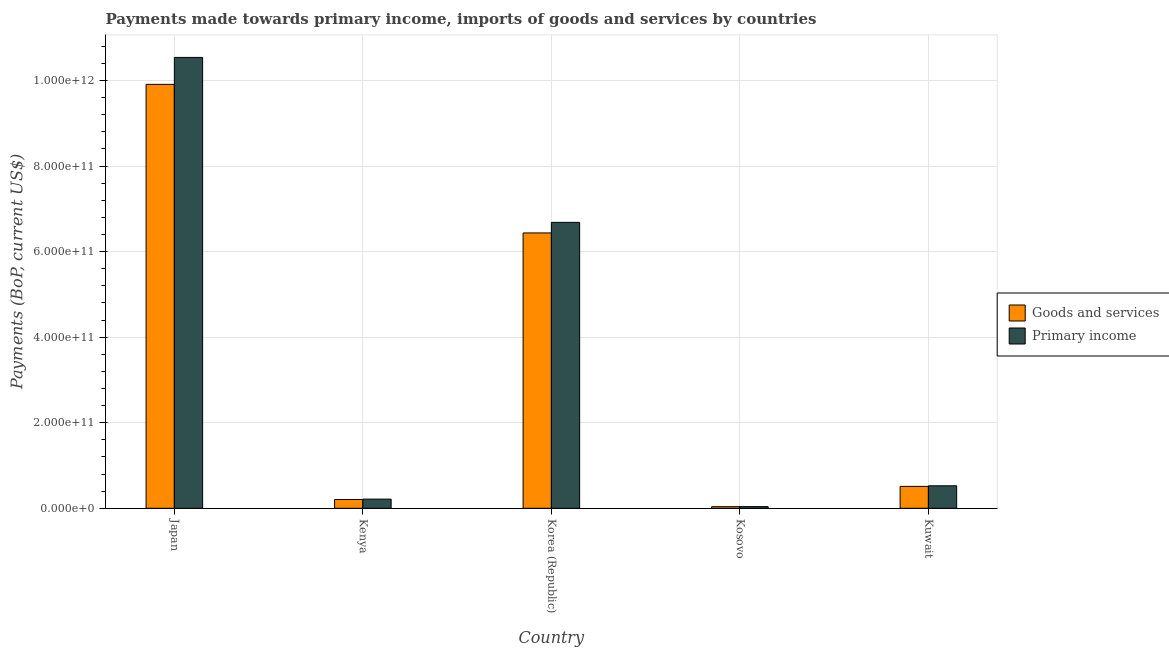Are the number of bars per tick equal to the number of legend labels?
Make the answer very short. Yes. Are the number of bars on each tick of the X-axis equal?
Offer a terse response. Yes. How many bars are there on the 2nd tick from the right?
Provide a succinct answer. 2. What is the label of the 4th group of bars from the left?
Keep it short and to the point. Kosovo. What is the payments made towards goods and services in Kosovo?
Provide a short and direct response. 3.73e+09. Across all countries, what is the maximum payments made towards primary income?
Provide a succinct answer. 1.05e+12. Across all countries, what is the minimum payments made towards goods and services?
Make the answer very short. 3.73e+09. In which country was the payments made towards goods and services maximum?
Provide a succinct answer. Japan. In which country was the payments made towards primary income minimum?
Ensure brevity in your answer.  Kosovo. What is the total payments made towards goods and services in the graph?
Offer a terse response. 1.71e+12. What is the difference between the payments made towards goods and services in Japan and that in Kuwait?
Your answer should be very brief. 9.40e+11. What is the difference between the payments made towards primary income in Japan and the payments made towards goods and services in Korea (Republic)?
Keep it short and to the point. 4.10e+11. What is the average payments made towards primary income per country?
Give a very brief answer. 3.60e+11. What is the difference between the payments made towards goods and services and payments made towards primary income in Japan?
Your answer should be compact. -6.30e+1. What is the ratio of the payments made towards goods and services in Korea (Republic) to that in Kosovo?
Offer a very short reply. 172.73. What is the difference between the highest and the second highest payments made towards goods and services?
Your answer should be very brief. 3.47e+11. What is the difference between the highest and the lowest payments made towards goods and services?
Provide a short and direct response. 9.87e+11. In how many countries, is the payments made towards primary income greater than the average payments made towards primary income taken over all countries?
Give a very brief answer. 2. What does the 2nd bar from the left in Kosovo represents?
Give a very brief answer. Primary income. What does the 1st bar from the right in Japan represents?
Your answer should be very brief. Primary income. Are all the bars in the graph horizontal?
Offer a very short reply. No. What is the difference between two consecutive major ticks on the Y-axis?
Offer a very short reply. 2.00e+11. How many legend labels are there?
Keep it short and to the point. 2. What is the title of the graph?
Provide a short and direct response. Payments made towards primary income, imports of goods and services by countries. What is the label or title of the Y-axis?
Your answer should be very brief. Payments (BoP, current US$). What is the Payments (BoP, current US$) of Goods and services in Japan?
Keep it short and to the point. 9.91e+11. What is the Payments (BoP, current US$) of Primary income in Japan?
Provide a succinct answer. 1.05e+12. What is the Payments (BoP, current US$) in Goods and services in Kenya?
Your answer should be compact. 2.05e+1. What is the Payments (BoP, current US$) in Primary income in Kenya?
Give a very brief answer. 2.14e+1. What is the Payments (BoP, current US$) of Goods and services in Korea (Republic)?
Offer a very short reply. 6.44e+11. What is the Payments (BoP, current US$) in Primary income in Korea (Republic)?
Your answer should be compact. 6.68e+11. What is the Payments (BoP, current US$) in Goods and services in Kosovo?
Provide a short and direct response. 3.73e+09. What is the Payments (BoP, current US$) in Primary income in Kosovo?
Your answer should be very brief. 3.86e+09. What is the Payments (BoP, current US$) of Goods and services in Kuwait?
Your response must be concise. 5.12e+1. What is the Payments (BoP, current US$) of Primary income in Kuwait?
Your response must be concise. 5.26e+1. Across all countries, what is the maximum Payments (BoP, current US$) of Goods and services?
Ensure brevity in your answer.  9.91e+11. Across all countries, what is the maximum Payments (BoP, current US$) in Primary income?
Make the answer very short. 1.05e+12. Across all countries, what is the minimum Payments (BoP, current US$) in Goods and services?
Your answer should be compact. 3.73e+09. Across all countries, what is the minimum Payments (BoP, current US$) of Primary income?
Ensure brevity in your answer.  3.86e+09. What is the total Payments (BoP, current US$) of Goods and services in the graph?
Your answer should be compact. 1.71e+12. What is the total Payments (BoP, current US$) in Primary income in the graph?
Your response must be concise. 1.80e+12. What is the difference between the Payments (BoP, current US$) in Goods and services in Japan and that in Kenya?
Keep it short and to the point. 9.70e+11. What is the difference between the Payments (BoP, current US$) in Primary income in Japan and that in Kenya?
Make the answer very short. 1.03e+12. What is the difference between the Payments (BoP, current US$) in Goods and services in Japan and that in Korea (Republic)?
Offer a very short reply. 3.47e+11. What is the difference between the Payments (BoP, current US$) of Primary income in Japan and that in Korea (Republic)?
Your answer should be compact. 3.86e+11. What is the difference between the Payments (BoP, current US$) in Goods and services in Japan and that in Kosovo?
Your response must be concise. 9.87e+11. What is the difference between the Payments (BoP, current US$) in Primary income in Japan and that in Kosovo?
Offer a very short reply. 1.05e+12. What is the difference between the Payments (BoP, current US$) in Goods and services in Japan and that in Kuwait?
Your answer should be compact. 9.40e+11. What is the difference between the Payments (BoP, current US$) of Primary income in Japan and that in Kuwait?
Offer a very short reply. 1.00e+12. What is the difference between the Payments (BoP, current US$) in Goods and services in Kenya and that in Korea (Republic)?
Your response must be concise. -6.23e+11. What is the difference between the Payments (BoP, current US$) of Primary income in Kenya and that in Korea (Republic)?
Provide a succinct answer. -6.47e+11. What is the difference between the Payments (BoP, current US$) in Goods and services in Kenya and that in Kosovo?
Ensure brevity in your answer.  1.68e+1. What is the difference between the Payments (BoP, current US$) in Primary income in Kenya and that in Kosovo?
Keep it short and to the point. 1.75e+1. What is the difference between the Payments (BoP, current US$) of Goods and services in Kenya and that in Kuwait?
Give a very brief answer. -3.06e+1. What is the difference between the Payments (BoP, current US$) in Primary income in Kenya and that in Kuwait?
Provide a succinct answer. -3.12e+1. What is the difference between the Payments (BoP, current US$) in Goods and services in Korea (Republic) and that in Kosovo?
Provide a short and direct response. 6.40e+11. What is the difference between the Payments (BoP, current US$) in Primary income in Korea (Republic) and that in Kosovo?
Provide a short and direct response. 6.64e+11. What is the difference between the Payments (BoP, current US$) in Goods and services in Korea (Republic) and that in Kuwait?
Give a very brief answer. 5.92e+11. What is the difference between the Payments (BoP, current US$) in Primary income in Korea (Republic) and that in Kuwait?
Provide a short and direct response. 6.16e+11. What is the difference between the Payments (BoP, current US$) in Goods and services in Kosovo and that in Kuwait?
Keep it short and to the point. -4.74e+1. What is the difference between the Payments (BoP, current US$) of Primary income in Kosovo and that in Kuwait?
Keep it short and to the point. -4.87e+1. What is the difference between the Payments (BoP, current US$) of Goods and services in Japan and the Payments (BoP, current US$) of Primary income in Kenya?
Offer a very short reply. 9.70e+11. What is the difference between the Payments (BoP, current US$) of Goods and services in Japan and the Payments (BoP, current US$) of Primary income in Korea (Republic)?
Your answer should be very brief. 3.23e+11. What is the difference between the Payments (BoP, current US$) of Goods and services in Japan and the Payments (BoP, current US$) of Primary income in Kosovo?
Provide a succinct answer. 9.87e+11. What is the difference between the Payments (BoP, current US$) in Goods and services in Japan and the Payments (BoP, current US$) in Primary income in Kuwait?
Offer a terse response. 9.38e+11. What is the difference between the Payments (BoP, current US$) of Goods and services in Kenya and the Payments (BoP, current US$) of Primary income in Korea (Republic)?
Give a very brief answer. -6.48e+11. What is the difference between the Payments (BoP, current US$) in Goods and services in Kenya and the Payments (BoP, current US$) in Primary income in Kosovo?
Offer a very short reply. 1.67e+1. What is the difference between the Payments (BoP, current US$) in Goods and services in Kenya and the Payments (BoP, current US$) in Primary income in Kuwait?
Make the answer very short. -3.20e+1. What is the difference between the Payments (BoP, current US$) of Goods and services in Korea (Republic) and the Payments (BoP, current US$) of Primary income in Kosovo?
Keep it short and to the point. 6.40e+11. What is the difference between the Payments (BoP, current US$) in Goods and services in Korea (Republic) and the Payments (BoP, current US$) in Primary income in Kuwait?
Offer a terse response. 5.91e+11. What is the difference between the Payments (BoP, current US$) in Goods and services in Kosovo and the Payments (BoP, current US$) in Primary income in Kuwait?
Your answer should be very brief. -4.88e+1. What is the average Payments (BoP, current US$) of Goods and services per country?
Provide a succinct answer. 3.42e+11. What is the average Payments (BoP, current US$) in Primary income per country?
Your response must be concise. 3.60e+11. What is the difference between the Payments (BoP, current US$) of Goods and services and Payments (BoP, current US$) of Primary income in Japan?
Give a very brief answer. -6.30e+1. What is the difference between the Payments (BoP, current US$) of Goods and services and Payments (BoP, current US$) of Primary income in Kenya?
Offer a very short reply. -8.64e+08. What is the difference between the Payments (BoP, current US$) in Goods and services and Payments (BoP, current US$) in Primary income in Korea (Republic)?
Your response must be concise. -2.47e+1. What is the difference between the Payments (BoP, current US$) of Goods and services and Payments (BoP, current US$) of Primary income in Kosovo?
Ensure brevity in your answer.  -1.35e+08. What is the difference between the Payments (BoP, current US$) in Goods and services and Payments (BoP, current US$) in Primary income in Kuwait?
Keep it short and to the point. -1.39e+09. What is the ratio of the Payments (BoP, current US$) in Goods and services in Japan to that in Kenya?
Your answer should be very brief. 48.24. What is the ratio of the Payments (BoP, current US$) in Primary income in Japan to that in Kenya?
Offer a terse response. 49.23. What is the ratio of the Payments (BoP, current US$) in Goods and services in Japan to that in Korea (Republic)?
Your answer should be very brief. 1.54. What is the ratio of the Payments (BoP, current US$) in Primary income in Japan to that in Korea (Republic)?
Keep it short and to the point. 1.58. What is the ratio of the Payments (BoP, current US$) in Goods and services in Japan to that in Kosovo?
Keep it short and to the point. 265.94. What is the ratio of the Payments (BoP, current US$) in Primary income in Japan to that in Kosovo?
Give a very brief answer. 272.95. What is the ratio of the Payments (BoP, current US$) of Goods and services in Japan to that in Kuwait?
Provide a succinct answer. 19.36. What is the ratio of the Payments (BoP, current US$) in Primary income in Japan to that in Kuwait?
Your answer should be compact. 20.05. What is the ratio of the Payments (BoP, current US$) in Goods and services in Kenya to that in Korea (Republic)?
Provide a succinct answer. 0.03. What is the ratio of the Payments (BoP, current US$) in Primary income in Kenya to that in Korea (Republic)?
Provide a short and direct response. 0.03. What is the ratio of the Payments (BoP, current US$) of Goods and services in Kenya to that in Kosovo?
Your answer should be compact. 5.51. What is the ratio of the Payments (BoP, current US$) of Primary income in Kenya to that in Kosovo?
Your answer should be compact. 5.54. What is the ratio of the Payments (BoP, current US$) of Goods and services in Kenya to that in Kuwait?
Ensure brevity in your answer.  0.4. What is the ratio of the Payments (BoP, current US$) of Primary income in Kenya to that in Kuwait?
Offer a terse response. 0.41. What is the ratio of the Payments (BoP, current US$) in Goods and services in Korea (Republic) to that in Kosovo?
Offer a very short reply. 172.73. What is the ratio of the Payments (BoP, current US$) of Primary income in Korea (Republic) to that in Kosovo?
Provide a short and direct response. 173.09. What is the ratio of the Payments (BoP, current US$) in Goods and services in Korea (Republic) to that in Kuwait?
Give a very brief answer. 12.58. What is the ratio of the Payments (BoP, current US$) in Primary income in Korea (Republic) to that in Kuwait?
Your response must be concise. 12.71. What is the ratio of the Payments (BoP, current US$) of Goods and services in Kosovo to that in Kuwait?
Offer a terse response. 0.07. What is the ratio of the Payments (BoP, current US$) of Primary income in Kosovo to that in Kuwait?
Make the answer very short. 0.07. What is the difference between the highest and the second highest Payments (BoP, current US$) in Goods and services?
Ensure brevity in your answer.  3.47e+11. What is the difference between the highest and the second highest Payments (BoP, current US$) of Primary income?
Offer a very short reply. 3.86e+11. What is the difference between the highest and the lowest Payments (BoP, current US$) in Goods and services?
Your answer should be compact. 9.87e+11. What is the difference between the highest and the lowest Payments (BoP, current US$) in Primary income?
Make the answer very short. 1.05e+12. 